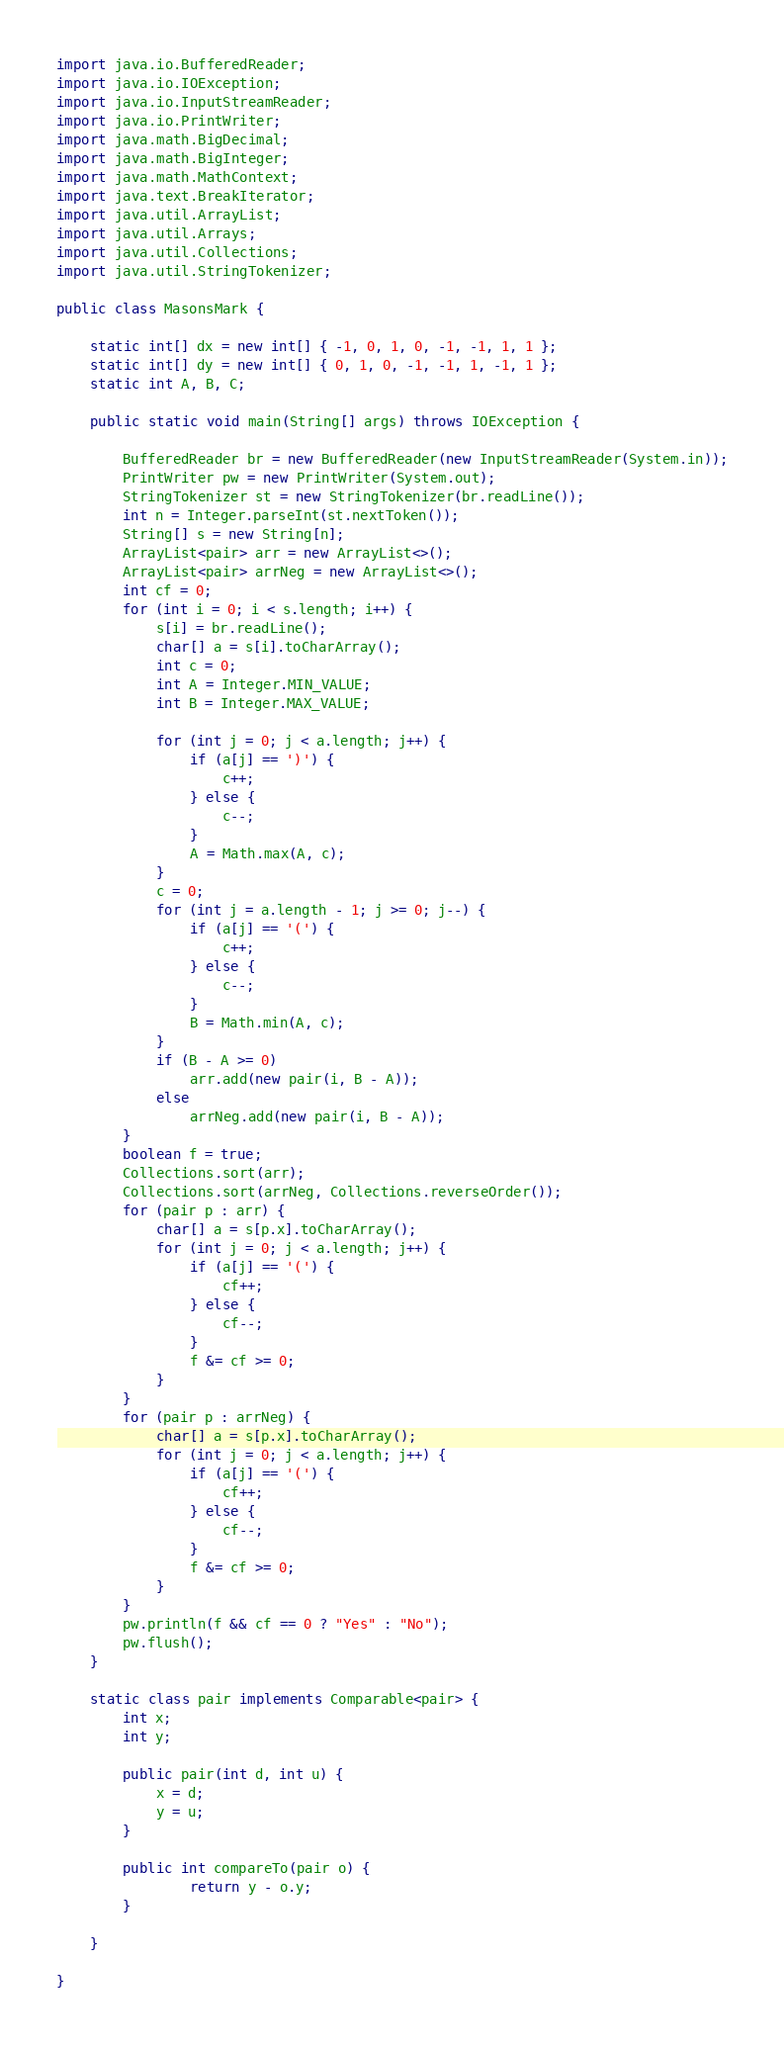<code> <loc_0><loc_0><loc_500><loc_500><_Java_>import java.io.BufferedReader;
import java.io.IOException;
import java.io.InputStreamReader;
import java.io.PrintWriter;
import java.math.BigDecimal;
import java.math.BigInteger;
import java.math.MathContext;
import java.text.BreakIterator;
import java.util.ArrayList;
import java.util.Arrays;
import java.util.Collections;
import java.util.StringTokenizer;

public class MasonsMark {

	static int[] dx = new int[] { -1, 0, 1, 0, -1, -1, 1, 1 };
	static int[] dy = new int[] { 0, 1, 0, -1, -1, 1, -1, 1 };
	static int A, B, C;

	public static void main(String[] args) throws IOException {

		BufferedReader br = new BufferedReader(new InputStreamReader(System.in));
		PrintWriter pw = new PrintWriter(System.out);
		StringTokenizer st = new StringTokenizer(br.readLine());
		int n = Integer.parseInt(st.nextToken());
		String[] s = new String[n];
		ArrayList<pair> arr = new ArrayList<>();
		ArrayList<pair> arrNeg = new ArrayList<>();
		int cf = 0;
		for (int i = 0; i < s.length; i++) {
			s[i] = br.readLine();
			char[] a = s[i].toCharArray();
			int c = 0;
			int A = Integer.MIN_VALUE;
			int B = Integer.MAX_VALUE;

			for (int j = 0; j < a.length; j++) {
				if (a[j] == ')') {
					c++;
				} else {
					c--;
				}
				A = Math.max(A, c);
			}
			c = 0;
			for (int j = a.length - 1; j >= 0; j--) {
				if (a[j] == '(') {
					c++;
				} else {
					c--;
				}
				B = Math.min(A, c);
			}
			if (B - A >= 0)
				arr.add(new pair(i, B - A));
			else
				arrNeg.add(new pair(i, B - A));
		}
		boolean f = true;
		Collections.sort(arr);
		Collections.sort(arrNeg, Collections.reverseOrder());
		for (pair p : arr) {
			char[] a = s[p.x].toCharArray();
			for (int j = 0; j < a.length; j++) {
				if (a[j] == '(') {
					cf++;
				} else {
					cf--;
				}
				f &= cf >= 0;
			}
		}
		for (pair p : arrNeg) {
			char[] a = s[p.x].toCharArray();
			for (int j = 0; j < a.length; j++) {
				if (a[j] == '(') {
					cf++;
				} else {
					cf--;
				}
				f &= cf >= 0;
			}
		}
		pw.println(f && cf == 0 ? "Yes" : "No");
		pw.flush();
	}

	static class pair implements Comparable<pair> {
		int x;
		int y;

		public pair(int d, int u) {
			x = d;
			y = u;
		}

		public int compareTo(pair o) {
				return y - o.y;
		}

	}

}
</code> 